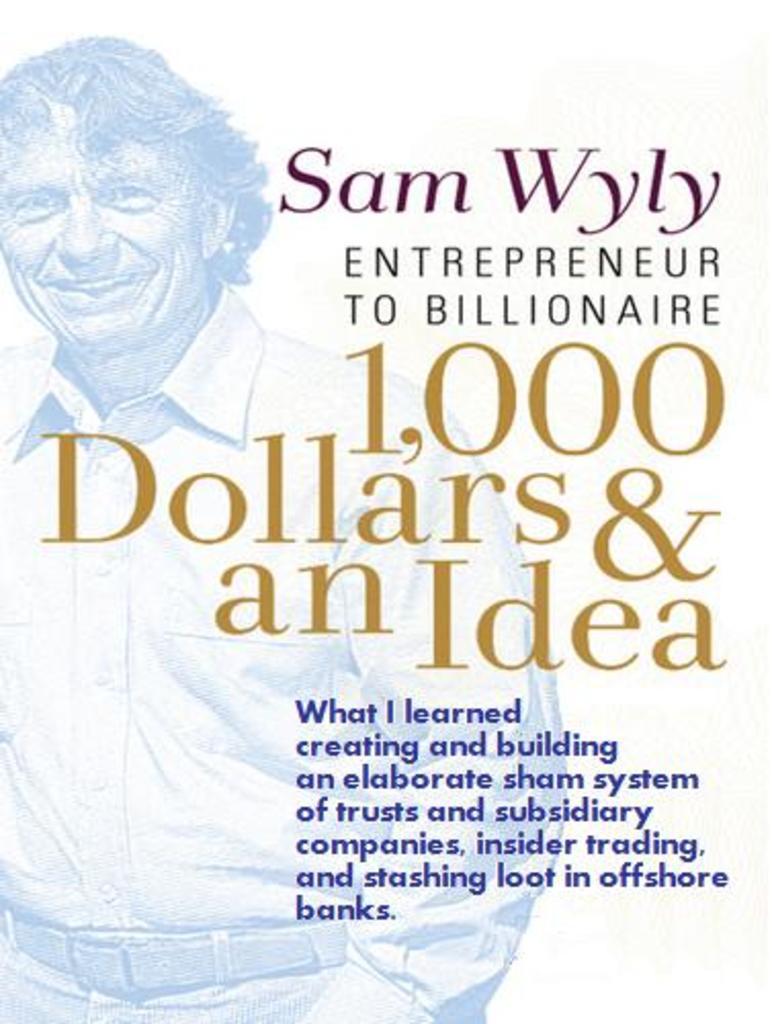How would you summarize this image in a sentence or two? In the picture I can see the poster. On the poster I can see a man wearing shirt and there is a smile on his face. I can see the text on the right side. 